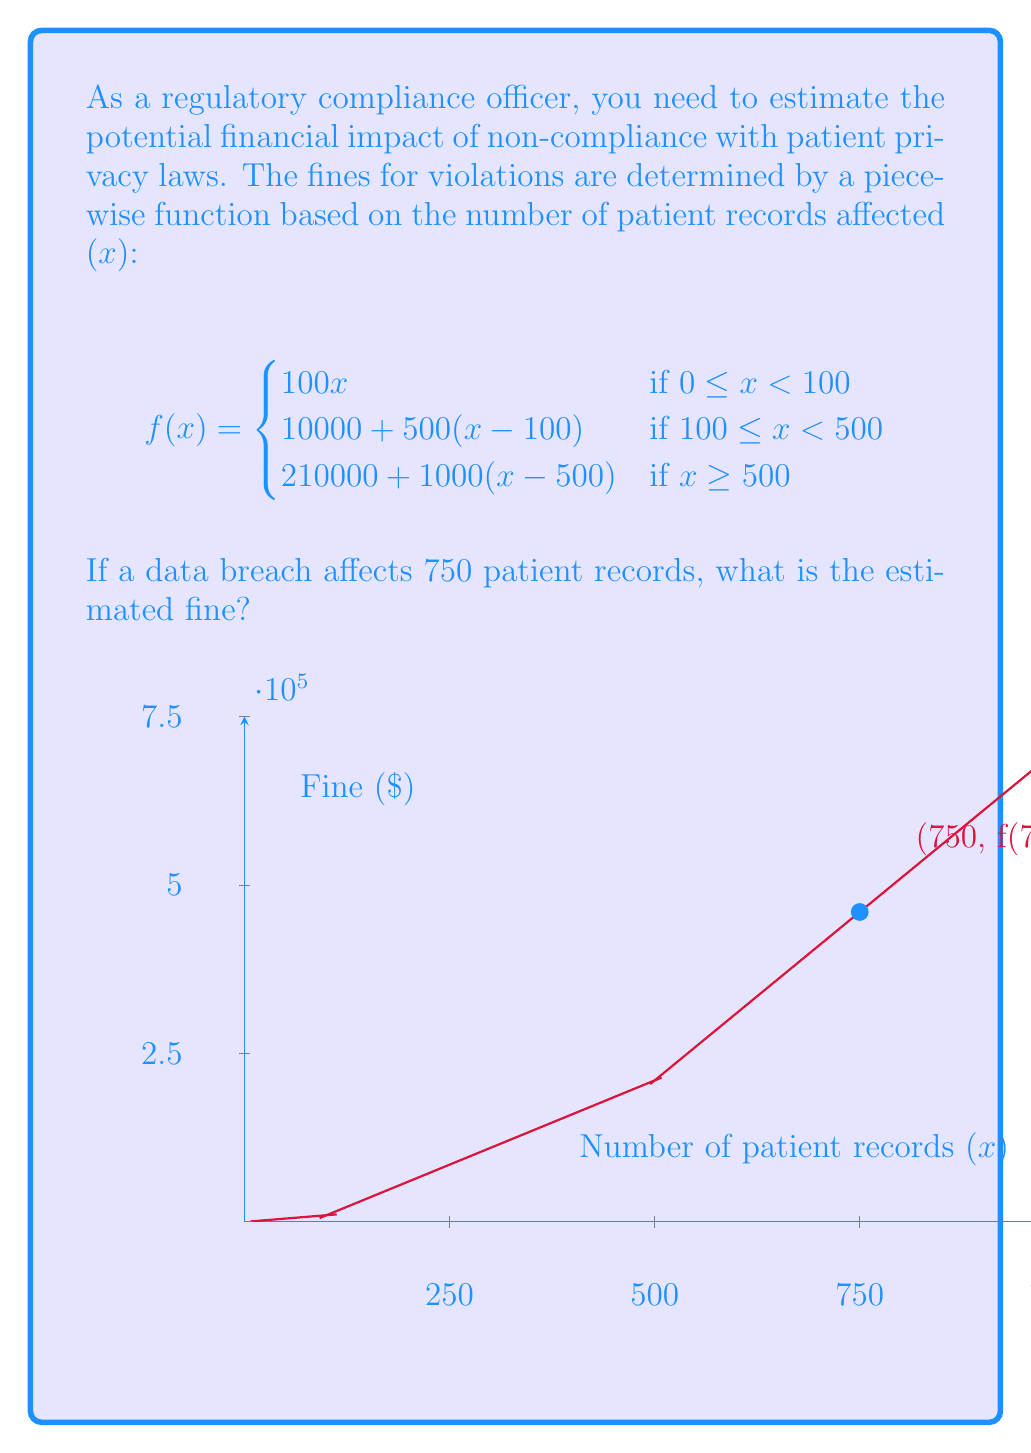Teach me how to tackle this problem. To solve this problem, we need to use the appropriate piece of the piecewise function for 750 patient records:

1. Determine which piece of the function applies:
   750 is greater than or equal to 500, so we use the third piece of the function.

2. Apply the function:
   $$f(x) = 210000 + 1000(x-500)$$ where $x = 750$

3. Calculate the fine:
   $$\begin{align}
   f(750) &= 210000 + 1000(750-500) \\
   &= 210000 + 1000(250) \\
   &= 210000 + 250000 \\
   &= 460000
   \end{align}$$

Therefore, the estimated fine for a data breach affecting 750 patient records is $460,000.
Answer: $460,000 